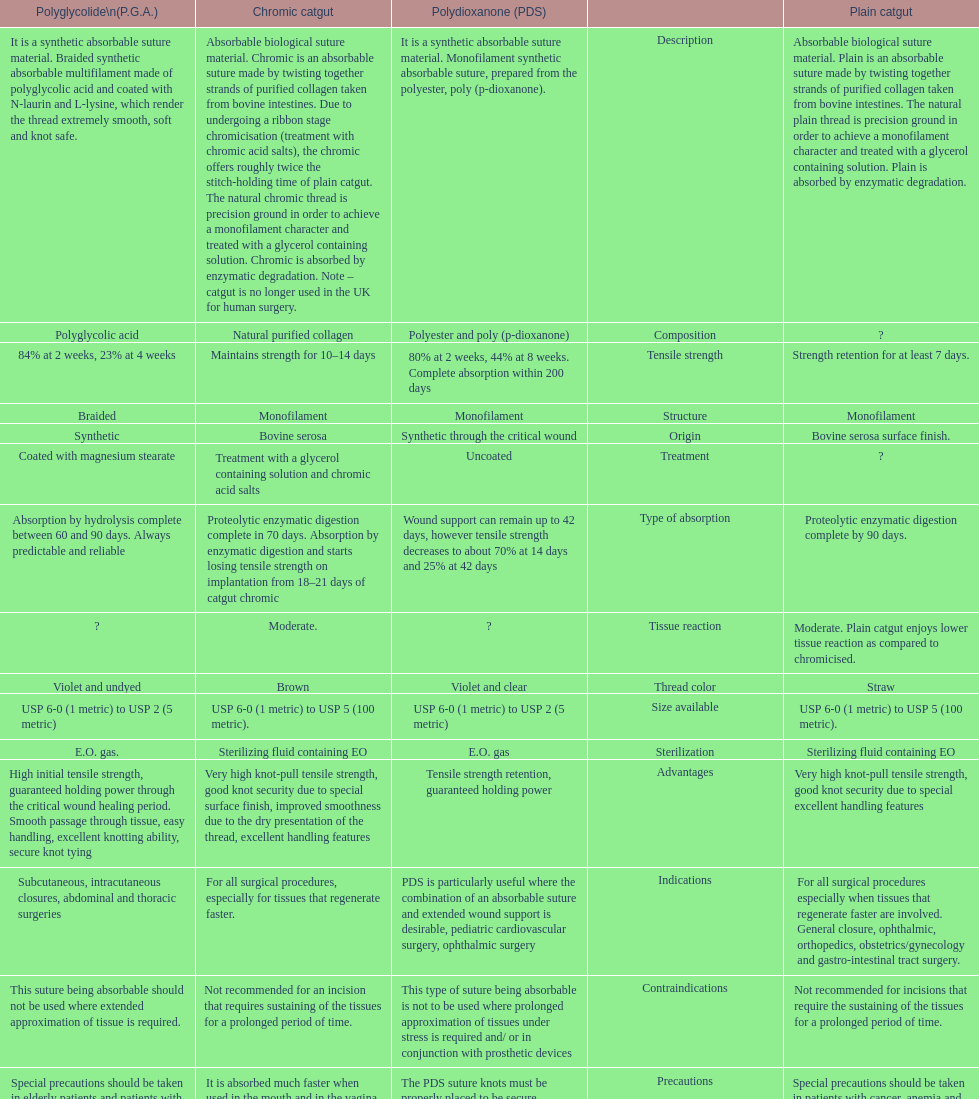Which suture can remain to at most 42 days Polydioxanone (PDS). 